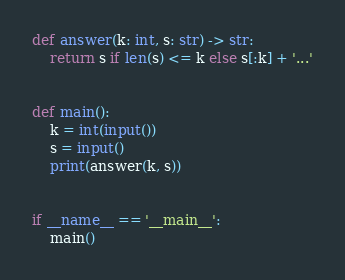Convert code to text. <code><loc_0><loc_0><loc_500><loc_500><_Python_>def answer(k: int, s: str) -> str:
    return s if len(s) <= k else s[:k] + '...'


def main():
    k = int(input())
    s = input()
    print(answer(k, s))


if __name__ == '__main__':
    main()</code> 